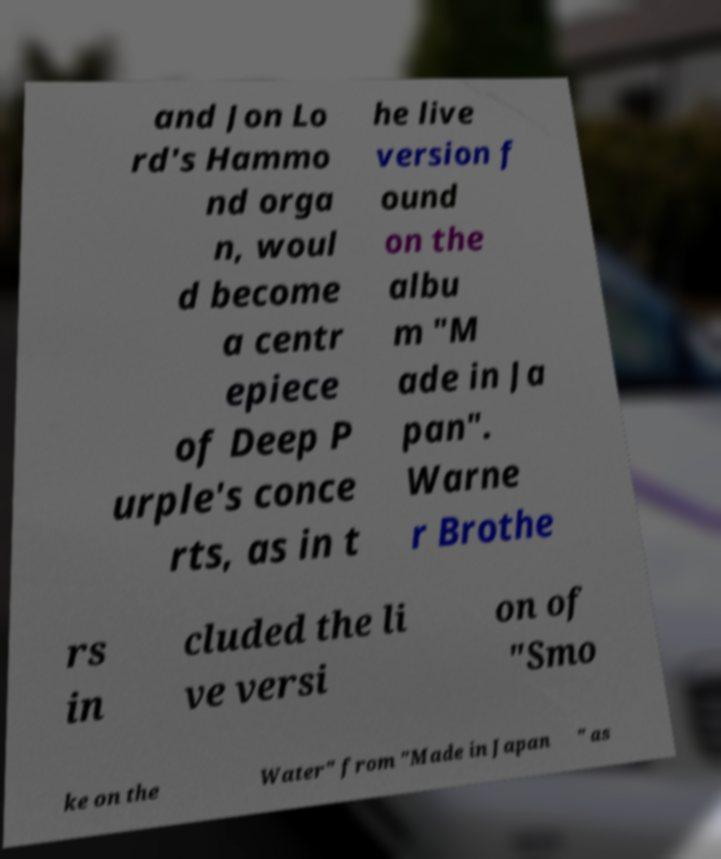What messages or text are displayed in this image? I need them in a readable, typed format. and Jon Lo rd's Hammo nd orga n, woul d become a centr epiece of Deep P urple's conce rts, as in t he live version f ound on the albu m "M ade in Ja pan". Warne r Brothe rs in cluded the li ve versi on of "Smo ke on the Water" from "Made in Japan " as 